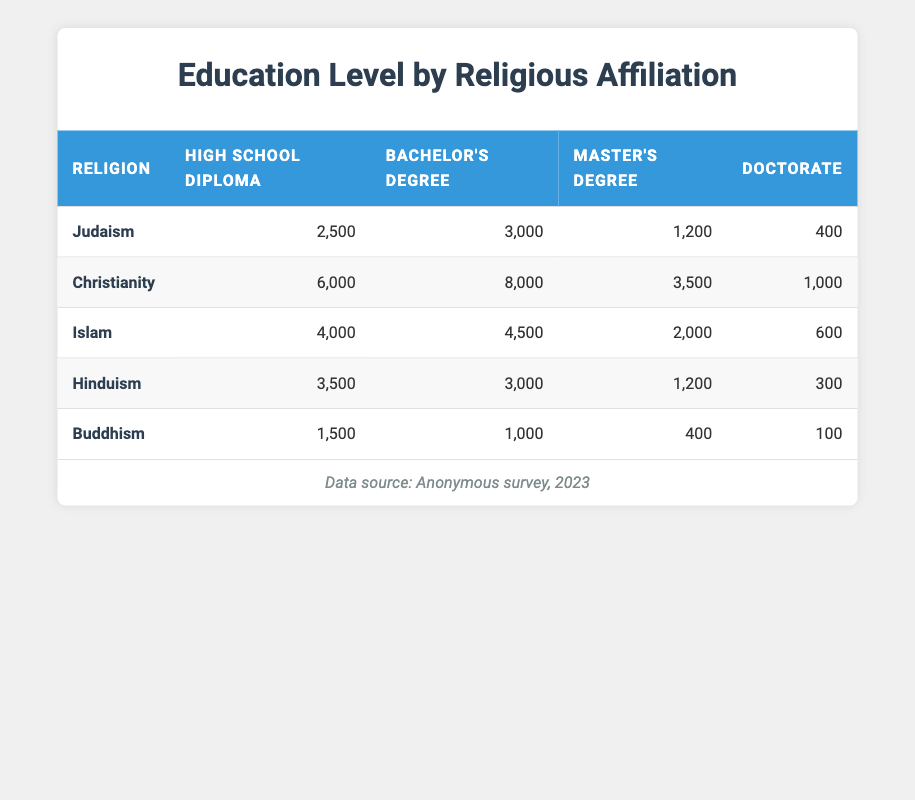What is the total number of individuals with a Bachelor's Degree in Judaism? The count for Bachelor's Degree in Judaism is given as 3,000. This is a direct retrieval from the table.
Answer: 3000 Which religion has the highest number of individuals with a High School Diploma? Christianity has the highest count for High School Diploma at 6,000. This can be quickly identified by comparing the numbers in the corresponding column.
Answer: Christianity What is the average number of individuals holding a Doctorate across all religions? To find the average, we sum the counts for Doctorate across all religions: 400 (Judaism) + 1000 (Christianity) + 600 (Islam) + 300 (Hinduism) + 100 (Buddhism) = 2400. There are 5 religions, so the average is 2400/5 = 480.
Answer: 480 Is it true that the number of individuals with a Master’s Degree in Islam is greater than that in Christianity? The count for Master's Degree in Islam is 2,000 while in Christianity it is 3,500. Since 2,000 is less than 3,500, the statement is false.
Answer: False What is the difference in the number of individuals with a High School Diploma between Christianity and Buddhism? For Christianity, the count for High School Diploma is 6,000 and for Buddhism it is 1,500. The difference is 6000 - 1500 = 4500.
Answer: 4500 What percentage of individuals in Hinduism have attained a Doctorate? In Hinduism, there are 300 individuals with a Doctorate out of a total of 3,500 (High School) + 3,000 (Bachelor's) + 1,200 (Master's) + 300 (Doctorate) = 8,000 individuals. The percentage is calculated as (300/8000) * 100 = 3.75%.
Answer: 3.75% How many more individuals with a Master's Degree are in Christianity compared to Judaism? The count for Master's Degree in Christianity is 3,500 and in Judaism, it is 1,200. The difference is 3500 - 1200 = 2300.
Answer: 2300 Is the total number of individuals with any degree in Buddhism higher than in Judaism? The total in Buddhism is 1500 (High School) + 1000 (Bachelor's) + 400 (Master's) + 100 (Doctorate) = 3000. In Judaism, the total is 2500 + 3000 + 1200 + 400 = 7000. Since 3000 is less than 7000, the statement is false.
Answer: False 